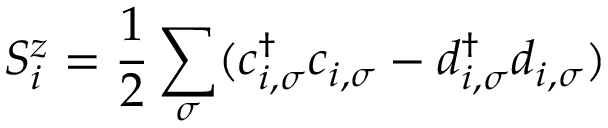<formula> <loc_0><loc_0><loc_500><loc_500>S _ { i } ^ { z } = \frac { 1 } { 2 } \sum _ { \sigma } ( c _ { i , \sigma } ^ { \dag } c _ { i , \sigma } - d _ { i , \sigma } ^ { \dag } d _ { i , \sigma } )</formula> 